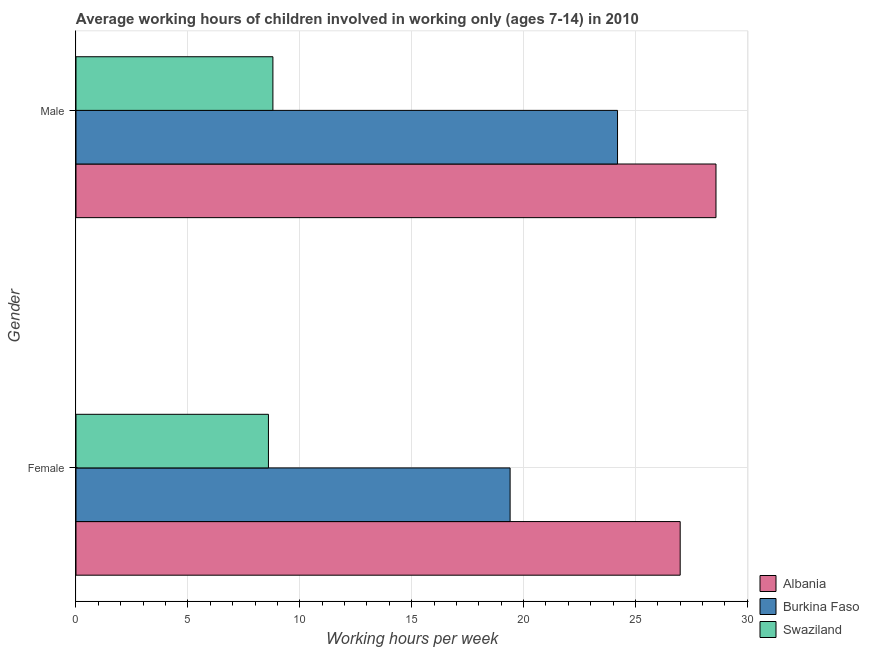How many different coloured bars are there?
Your response must be concise. 3. Are the number of bars per tick equal to the number of legend labels?
Give a very brief answer. Yes. How many bars are there on the 1st tick from the bottom?
Provide a short and direct response. 3. What is the label of the 2nd group of bars from the top?
Provide a succinct answer. Female. What is the average working hour of female children in Burkina Faso?
Offer a terse response. 19.4. Across all countries, what is the minimum average working hour of female children?
Your response must be concise. 8.6. In which country was the average working hour of female children maximum?
Provide a succinct answer. Albania. In which country was the average working hour of female children minimum?
Your answer should be very brief. Swaziland. What is the total average working hour of male children in the graph?
Provide a succinct answer. 61.6. What is the difference between the average working hour of male children in Burkina Faso and that in Swaziland?
Your response must be concise. 15.4. What is the difference between the average working hour of male children in Burkina Faso and the average working hour of female children in Swaziland?
Provide a short and direct response. 15.6. What is the average average working hour of female children per country?
Provide a succinct answer. 18.33. What is the difference between the average working hour of male children and average working hour of female children in Burkina Faso?
Give a very brief answer. 4.8. What is the ratio of the average working hour of female children in Albania to that in Burkina Faso?
Give a very brief answer. 1.39. What does the 2nd bar from the top in Female represents?
Ensure brevity in your answer.  Burkina Faso. What does the 3rd bar from the bottom in Female represents?
Ensure brevity in your answer.  Swaziland. How many bars are there?
Offer a very short reply. 6. Are all the bars in the graph horizontal?
Offer a very short reply. Yes. How many countries are there in the graph?
Keep it short and to the point. 3. How many legend labels are there?
Your response must be concise. 3. How are the legend labels stacked?
Your answer should be compact. Vertical. What is the title of the graph?
Your answer should be very brief. Average working hours of children involved in working only (ages 7-14) in 2010. What is the label or title of the X-axis?
Your answer should be compact. Working hours per week. What is the Working hours per week in Albania in Female?
Give a very brief answer. 27. What is the Working hours per week in Burkina Faso in Female?
Make the answer very short. 19.4. What is the Working hours per week in Swaziland in Female?
Your response must be concise. 8.6. What is the Working hours per week in Albania in Male?
Your answer should be very brief. 28.6. What is the Working hours per week of Burkina Faso in Male?
Offer a very short reply. 24.2. Across all Gender, what is the maximum Working hours per week of Albania?
Your response must be concise. 28.6. Across all Gender, what is the maximum Working hours per week of Burkina Faso?
Your answer should be very brief. 24.2. Across all Gender, what is the minimum Working hours per week in Swaziland?
Offer a terse response. 8.6. What is the total Working hours per week in Albania in the graph?
Your response must be concise. 55.6. What is the total Working hours per week of Burkina Faso in the graph?
Offer a terse response. 43.6. What is the difference between the Working hours per week of Burkina Faso in Female and that in Male?
Offer a very short reply. -4.8. What is the difference between the Working hours per week in Swaziland in Female and that in Male?
Your answer should be compact. -0.2. What is the difference between the Working hours per week in Albania in Female and the Working hours per week in Burkina Faso in Male?
Provide a short and direct response. 2.8. What is the average Working hours per week of Albania per Gender?
Your answer should be very brief. 27.8. What is the average Working hours per week of Burkina Faso per Gender?
Ensure brevity in your answer.  21.8. What is the difference between the Working hours per week in Albania and Working hours per week in Burkina Faso in Female?
Ensure brevity in your answer.  7.6. What is the difference between the Working hours per week of Albania and Working hours per week of Swaziland in Female?
Provide a succinct answer. 18.4. What is the difference between the Working hours per week of Albania and Working hours per week of Swaziland in Male?
Make the answer very short. 19.8. What is the ratio of the Working hours per week in Albania in Female to that in Male?
Offer a terse response. 0.94. What is the ratio of the Working hours per week in Burkina Faso in Female to that in Male?
Your answer should be compact. 0.8. What is the ratio of the Working hours per week of Swaziland in Female to that in Male?
Give a very brief answer. 0.98. What is the difference between the highest and the second highest Working hours per week in Albania?
Your answer should be compact. 1.6. What is the difference between the highest and the second highest Working hours per week in Burkina Faso?
Give a very brief answer. 4.8. What is the difference between the highest and the lowest Working hours per week in Swaziland?
Make the answer very short. 0.2. 